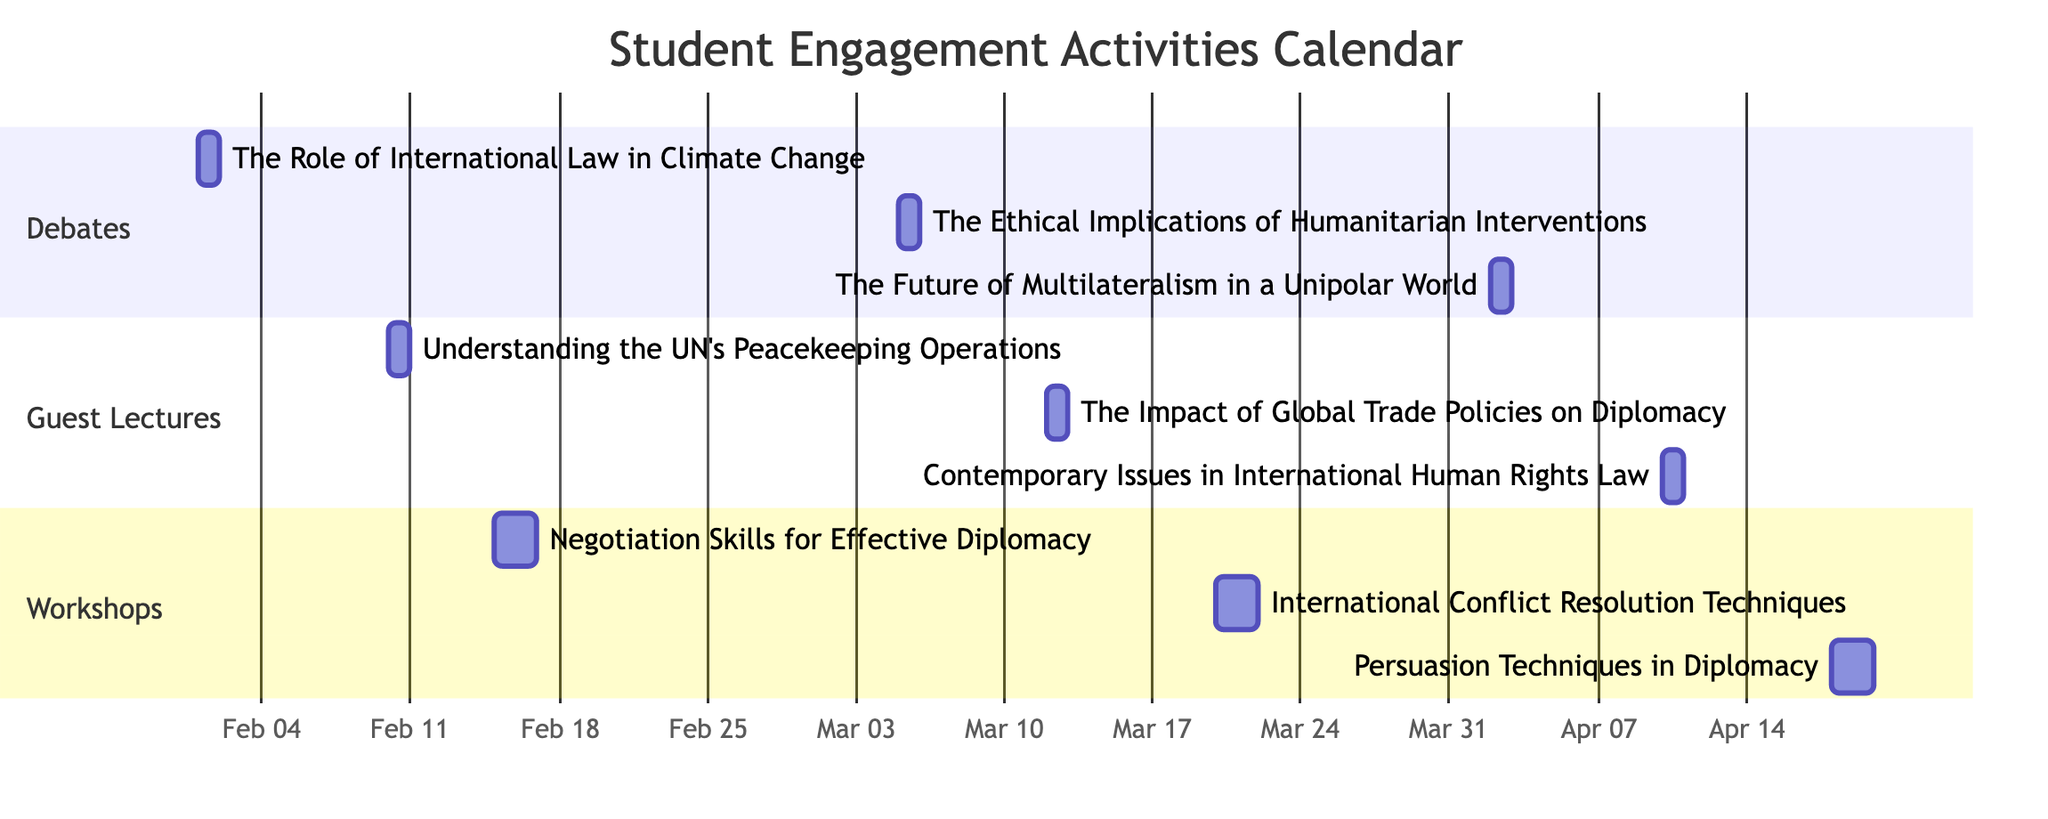what is the total number of activities planned for student engagement? The diagram displays three sections: Debates, Guest Lectures, and Workshops. Each section lists its respective activities. Counting all activities across these sections—3 debates, 3 guest lectures, and 3 workshops—results in a total of 9 activities.
Answer: 9 which activity is scheduled for February 10th? By examining the Guest Lectures section, it shows that the activity "Understanding the United Nations' Peacekeeping Operations" is scheduled for February 10th.
Answer: Understanding the United Nations' Peacekeeping Operations how many workshops are scheduled in March? Looking at the Workshops section, there are two activities listed in March: "International Conflict Resolution Techniques" and "Persuasion Techniques in Diplomacy." Therefore, the count of workshops in March is 2.
Answer: 2 when will the debate on humanitarian interventions take place? The diagram clearly lists the debates, and the entry shows that "The Ethical Implications of Humanitarian Interventions" is scheduled for March 5th.
Answer: March 5th which guest lecture occurs immediately after the workshop on negotiation skills? The timetable indicates that the workshop on negotiation skills takes place on February 15th and 16th, with the next guest lecture subsequently occurring on February 10th. Thus, it cannot be determined directly what comes after since it precedes the guest lecture; however, the following guest lecture occurs on March 12th.
Answer: The Impact of Global Trade Policies on Diplomacy how long does the workshop on persuasion techniques last? The workshops section shows that "Persuasion Techniques in Diplomacy" is planned for two days, specifically from April 18th to April 19th. To meet the requirements for the day's count, we confirm it lasts for 2 days.
Answer: 2 days which activity has been scheduled for the earliest date? The diagram's activities start on February 1st with "The Role of International Law in Climate Change," making it the first event on the calendar.
Answer: The Role of International Law in Climate Change what is the last event scheduled according to the calendar? Upon reviewing the final part of the diagram, the last activity listed is the workshop on "Persuasion Techniques in Diplomacy," which occurs on April 18th and 19th, making it the last scheduled event.
Answer: Persuasion Techniques in Diplomacy 